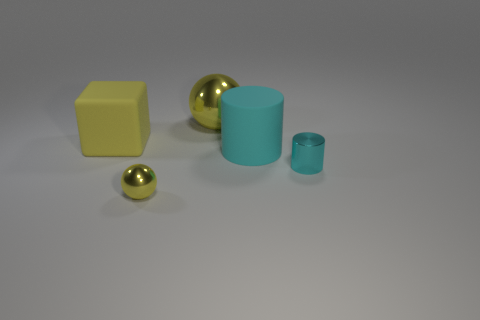Subtract all yellow cylinders. Subtract all brown blocks. How many cylinders are left? 2 Add 5 tiny cyan things. How many objects exist? 10 Subtract all cylinders. How many objects are left? 3 Add 5 big yellow shiny things. How many big yellow shiny things exist? 6 Subtract 0 purple balls. How many objects are left? 5 Subtract all large balls. Subtract all large brown rubber cylinders. How many objects are left? 4 Add 4 cyan matte cylinders. How many cyan matte cylinders are left? 5 